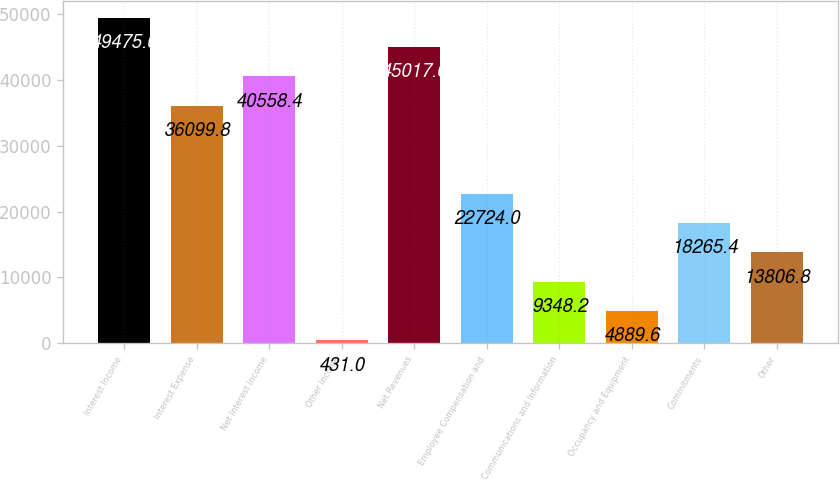Convert chart. <chart><loc_0><loc_0><loc_500><loc_500><bar_chart><fcel>Interest Income<fcel>Interest Expense<fcel>Net Interest Income<fcel>Other Income<fcel>Net Revenues<fcel>Employee Compensation and<fcel>Communications and Information<fcel>Occupancy and Equipment<fcel>Commitments<fcel>Other<nl><fcel>49475.6<fcel>36099.8<fcel>40558.4<fcel>431<fcel>45017<fcel>22724<fcel>9348.2<fcel>4889.6<fcel>18265.4<fcel>13806.8<nl></chart> 